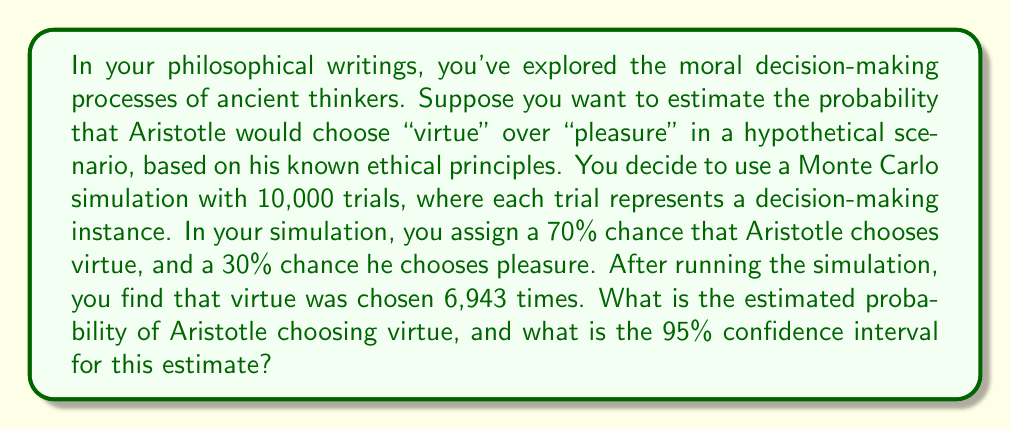Provide a solution to this math problem. To solve this problem, we'll follow these steps:

1. Calculate the estimated probability:
The estimated probability is simply the number of times virtue was chosen divided by the total number of trials.

$$ P(\text{virtue}) = \frac{6943}{10000} = 0.6943 $$

2. Calculate the standard error:
The standard error for a proportion is given by:

$$ SE = \sqrt{\frac{p(1-p)}{n}} $$

Where $p$ is the estimated probability and $n$ is the number of trials.

$$ SE = \sqrt{\frac{0.6943(1-0.6943)}{10000}} = 0.0046 $$

3. Calculate the 95% confidence interval:
For a 95% confidence interval, we use a z-score of 1.96. The formula is:

$$ CI = p \pm (1.96 \times SE) $$

Lower bound: $0.6943 - (1.96 \times 0.0046) = 0.6853$
Upper bound: $0.6943 + (1.96 \times 0.0046) = 0.7033$

Therefore, we can say with 95% confidence that the true probability of Aristotle choosing virtue lies between 0.6853 and 0.7033.
Answer: Estimated probability: 0.6943; 95% CI: (0.6853, 0.7033) 